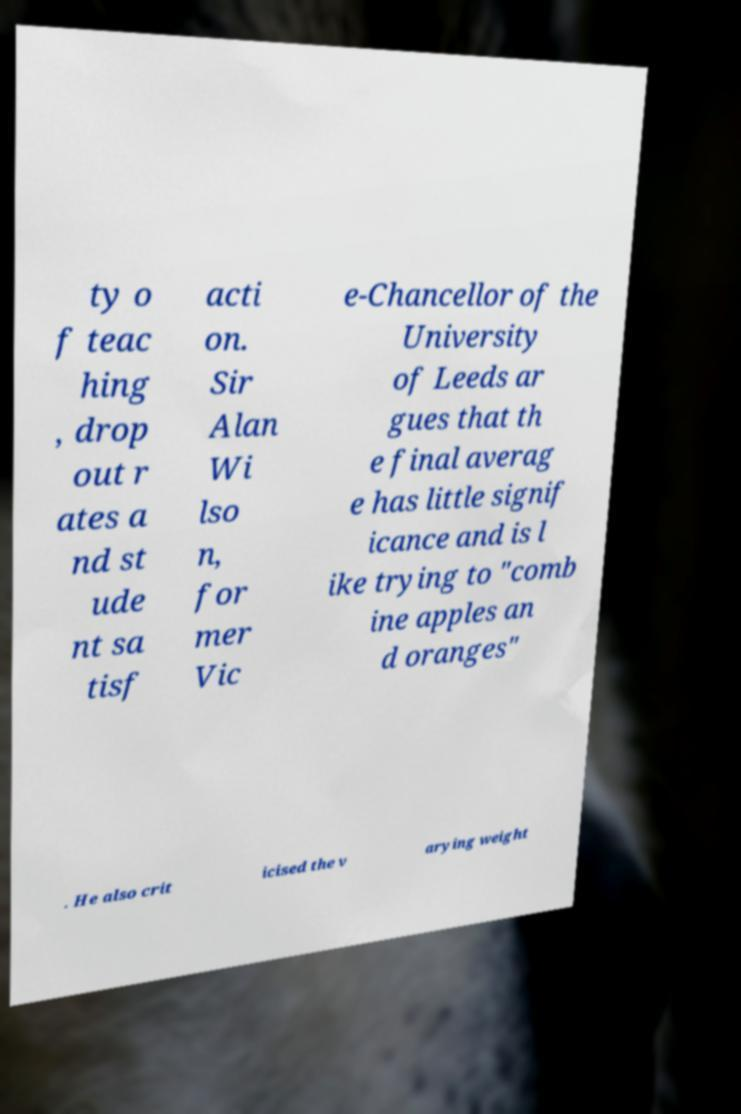Can you read and provide the text displayed in the image?This photo seems to have some interesting text. Can you extract and type it out for me? ty o f teac hing , drop out r ates a nd st ude nt sa tisf acti on. Sir Alan Wi lso n, for mer Vic e-Chancellor of the University of Leeds ar gues that th e final averag e has little signif icance and is l ike trying to "comb ine apples an d oranges" . He also crit icised the v arying weight 